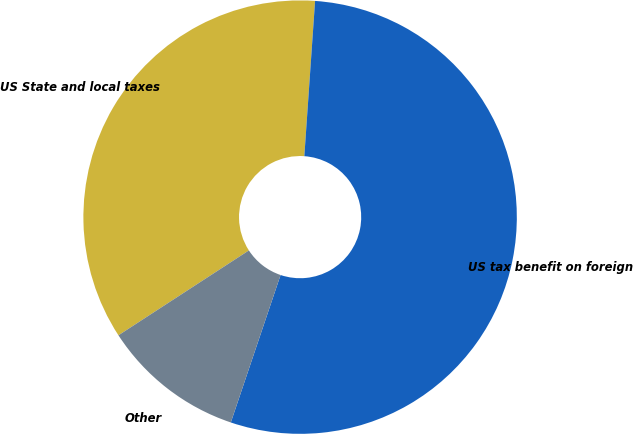Convert chart to OTSL. <chart><loc_0><loc_0><loc_500><loc_500><pie_chart><fcel>US State and local taxes<fcel>US tax benefit on foreign<fcel>Other<nl><fcel>35.28%<fcel>54.08%<fcel>10.64%<nl></chart> 